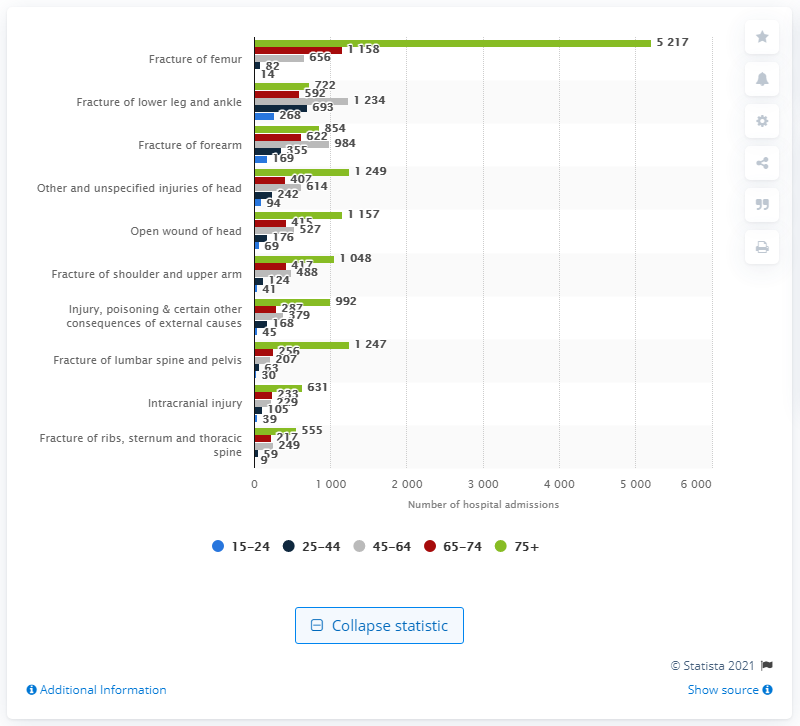List a handful of essential elements in this visual. In the year 2018/2019, a total of 5,217 individuals were admitted to the hospital due to a fractured femur as a result of a fall. 